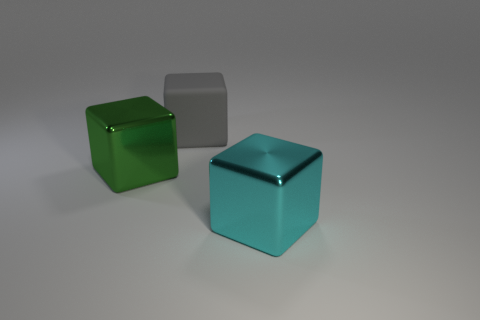How many brown things are balls or matte objects?
Provide a succinct answer. 0. Is the shape of the large metal object behind the cyan metal thing the same as the cyan thing that is in front of the green metal object?
Your answer should be compact. Yes. What number of other objects are there of the same material as the gray object?
Give a very brief answer. 0. There is a shiny cube behind the object to the right of the gray cube; is there a large green metallic object to the right of it?
Keep it short and to the point. No. Is the green thing made of the same material as the cyan object?
Provide a short and direct response. Yes. What material is the green thing behind the object that is right of the rubber block?
Your answer should be compact. Metal. There is a metallic object right of the big gray cube; what is its size?
Offer a very short reply. Large. The cube that is to the right of the big green metallic thing and in front of the large gray rubber thing is what color?
Provide a succinct answer. Cyan. Is the size of the metal object that is left of the cyan thing the same as the large cyan metal thing?
Your response must be concise. Yes. Is there a thing to the left of the block to the left of the big gray thing?
Your response must be concise. No. 